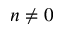<formula> <loc_0><loc_0><loc_500><loc_500>n \not = 0</formula> 